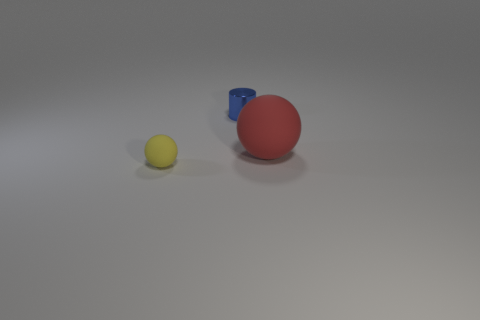Add 1 large red shiny cubes. How many objects exist? 4 Subtract all yellow spheres. How many spheres are left? 1 Subtract all cylinders. How many objects are left? 2 Subtract 2 balls. How many balls are left? 0 Subtract all tiny objects. Subtract all small balls. How many objects are left? 0 Add 2 small yellow matte things. How many small yellow matte things are left? 3 Add 3 small brown rubber things. How many small brown rubber things exist? 3 Subtract 0 yellow cubes. How many objects are left? 3 Subtract all yellow cylinders. Subtract all red spheres. How many cylinders are left? 1 